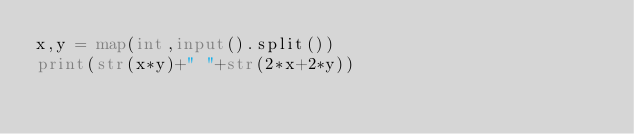<code> <loc_0><loc_0><loc_500><loc_500><_Python_>x,y = map(int,input().split())
print(str(x*y)+" "+str(2*x+2*y))
</code> 